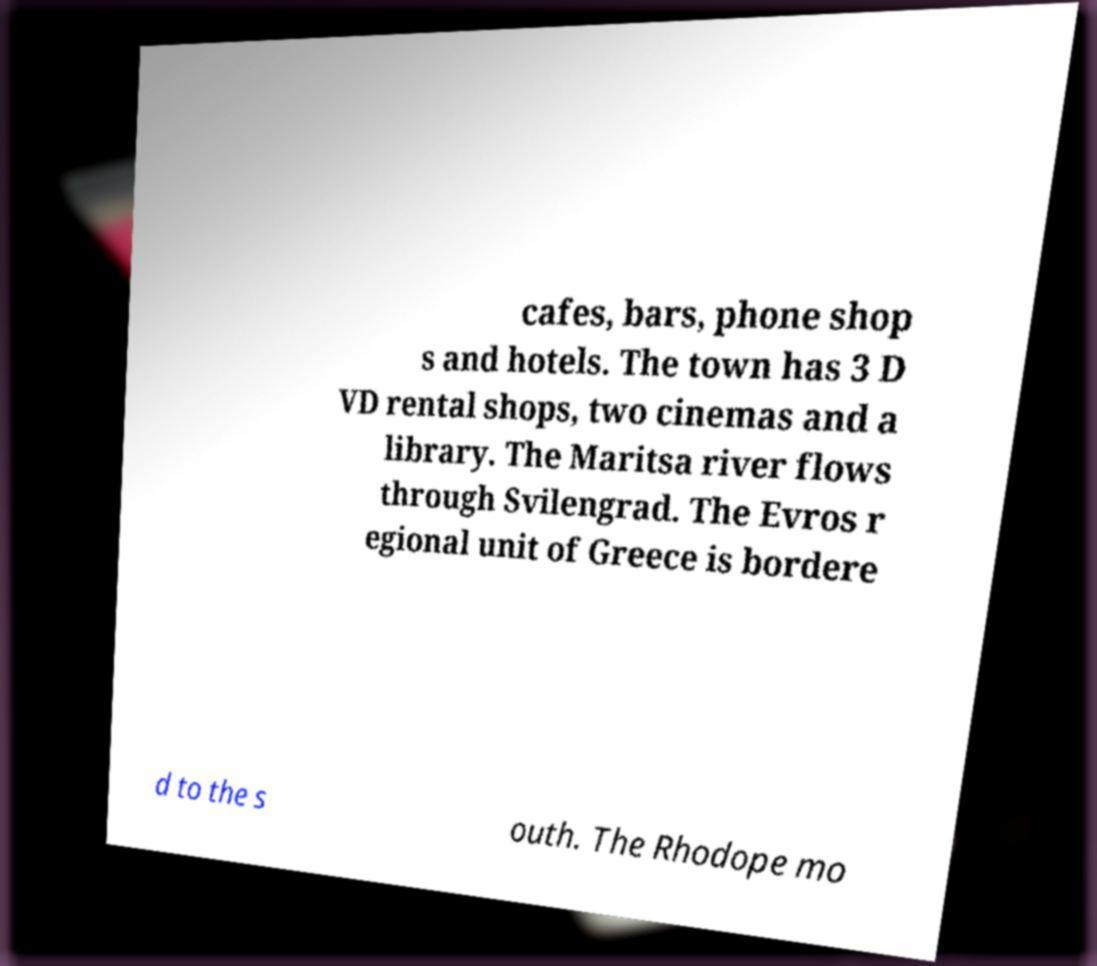What messages or text are displayed in this image? I need them in a readable, typed format. cafes, bars, phone shop s and hotels. The town has 3 D VD rental shops, two cinemas and a library. The Maritsa river flows through Svilengrad. The Evros r egional unit of Greece is bordere d to the s outh. The Rhodope mo 